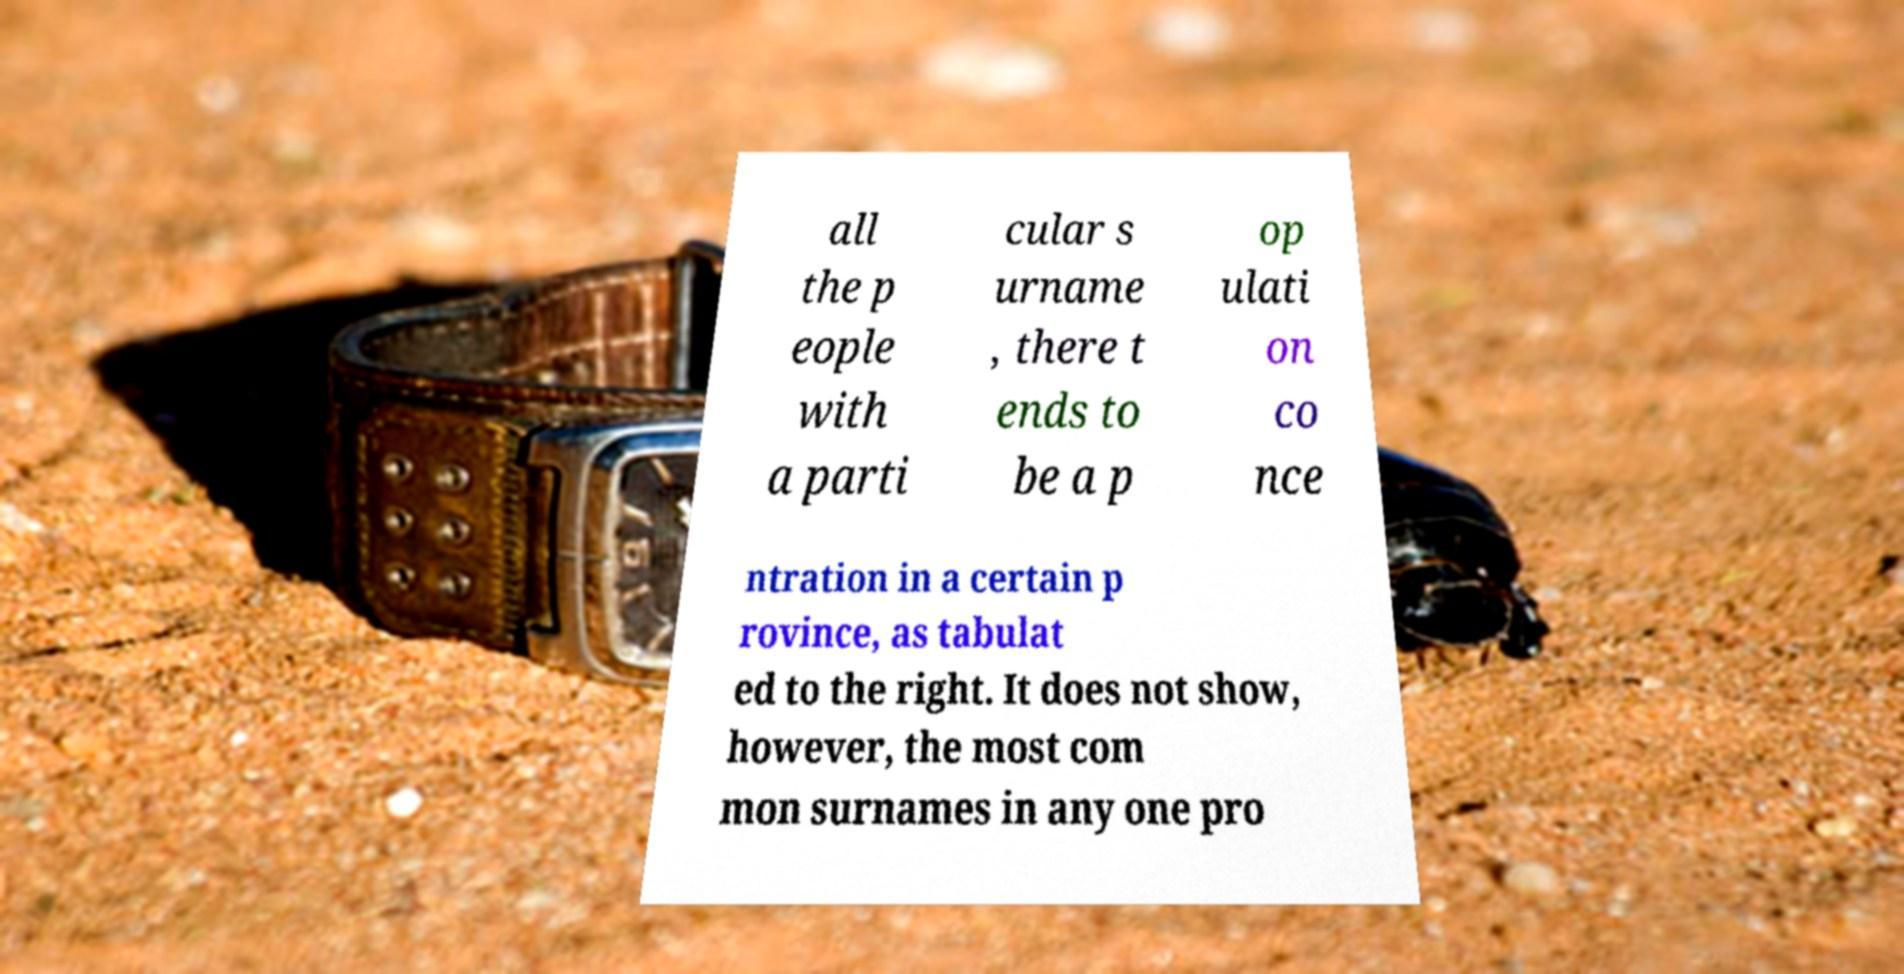Could you assist in decoding the text presented in this image and type it out clearly? all the p eople with a parti cular s urname , there t ends to be a p op ulati on co nce ntration in a certain p rovince, as tabulat ed to the right. It does not show, however, the most com mon surnames in any one pro 